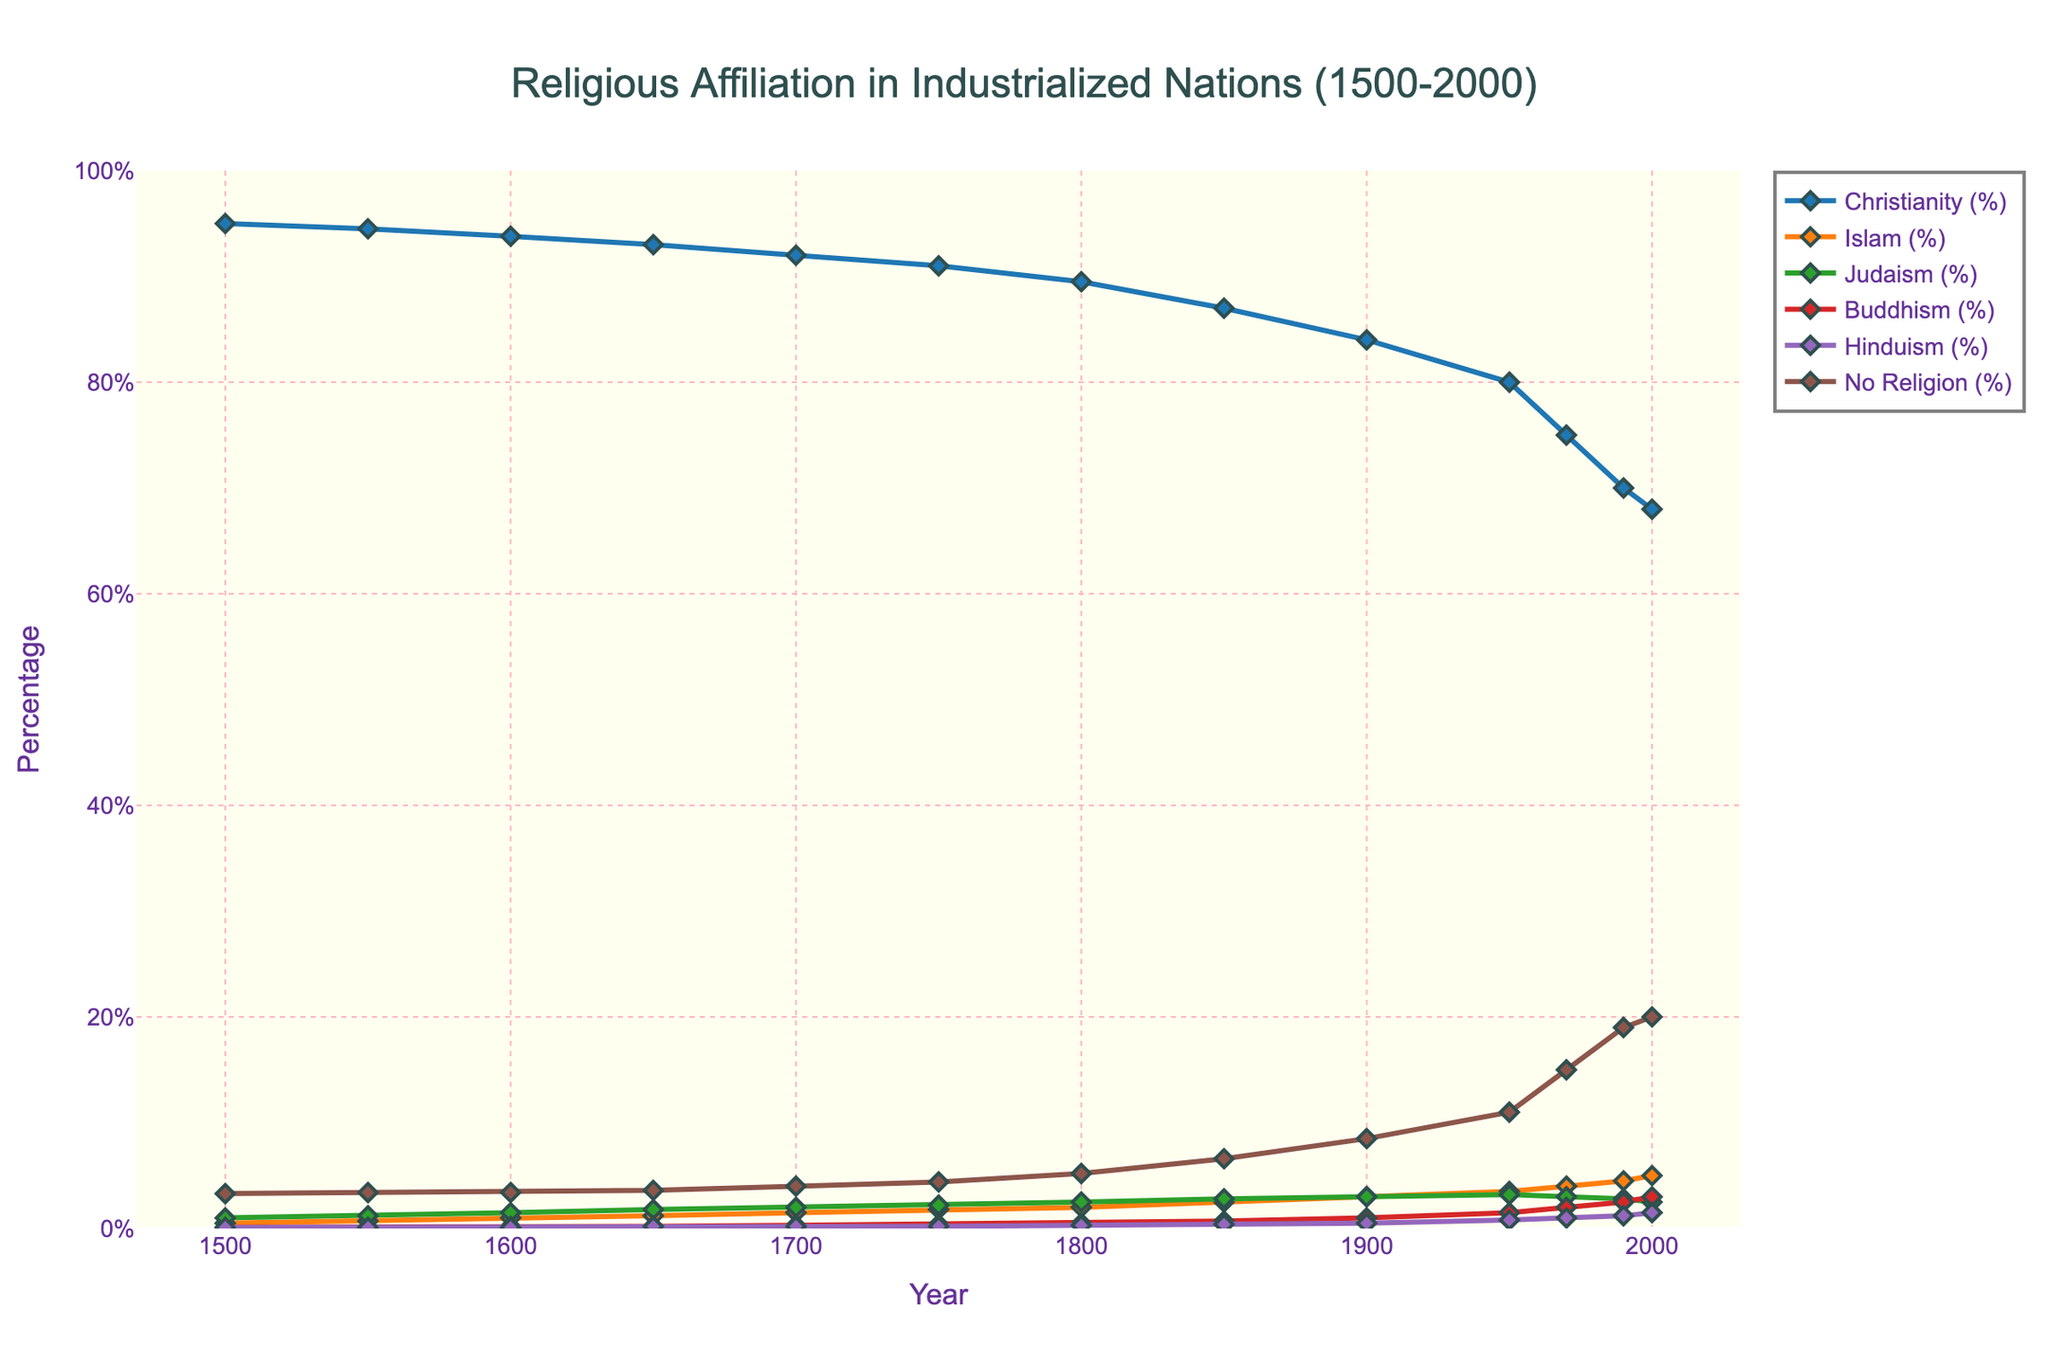What is the overall trend in the percentage of people with no religion from 1500 to 2000? To determine the trend, look at the line representing "No Religion (%)" on the chart. It starts at 3.3% in 1500 and increases to 20.0% in 2000. This indicates a consistent upward trend in the percentage of people with no religious affiliation over the period.
Answer: Increasing Between which years did Christianity experience the most significant percentage decline? To identify the period with the most significant decline for Christianity, examine the slope of the line representing "Christianity (%)". The steepest decline appears between 1950 and 1970, where the percentage drops from 80.0% to 75.0%.
Answer: 1950-1970 In what year did Islam surpass Judaism in terms of percentage of religious affiliation? Compare the lines representing "Islam (%)" and "Judaism (%)". Islam surpasses Judaism between 1850 and 1900, as Islam is at 2.5% and Judaism is at 2.8% in 1850, then Islam reaches 3.0% and Judaism remains at 3.0% by 1900. The exact crossover happens around 1900.
Answer: Around 1900 What is the combined percentage of Buddhism and Hinduism in the year 1800? Sum the values for Buddhism (%) and Hinduism (%) in 1800. Buddhism is at 0.5% and Hinduism is at 0.3%. The combined percentage is 0.5 + 0.3 = 0.8%.
Answer: 0.8% Which religion has the second-highest percentage in the year 2000? Look at the values for each religion in the year 2000. Christianity is the highest at 68.0%, and the second-highest percentage is Islam with 5.0%.
Answer: Islam How much did the percentage of people with no religion increase between 1500 and 2000? Subtract the percentage of people with no religion in 1500 from that in 2000. In 1500, it was 3.3%, and in 2000, it was 20.0%. The increase is 20.0 - 3.3 = 16.7 percentage points.
Answer: 16.7 percentage points Did Judaism's percentage ever exceed 3.0%? If so, in which years did this occur? Examine the line for "Judaism (%)" to see if it ever surpasses 3.0%. It reaches a peak of 3.2% around 1950 and never exceeds this value.
Answer: Around 1950 Which religion has the least variation in its percentage from 1500 to 2000? Evaluate the lines for all religions to find the one with the least fluctuations. Hinduism remains relatively stable, varying between 0.1% and 1.5%, showing minimal change compared to others.
Answer: Hinduism What is the difference in the percentage of Christianity between 1600 and 2000? Subtract the percentage of Christianity in 2000 from that in 1600. In 1600, it was 93.8%, and in 2000, it was 68.0%. The difference is 93.8 - 68.0 = 25.8 percentage points.
Answer: 25.8 percentage points 